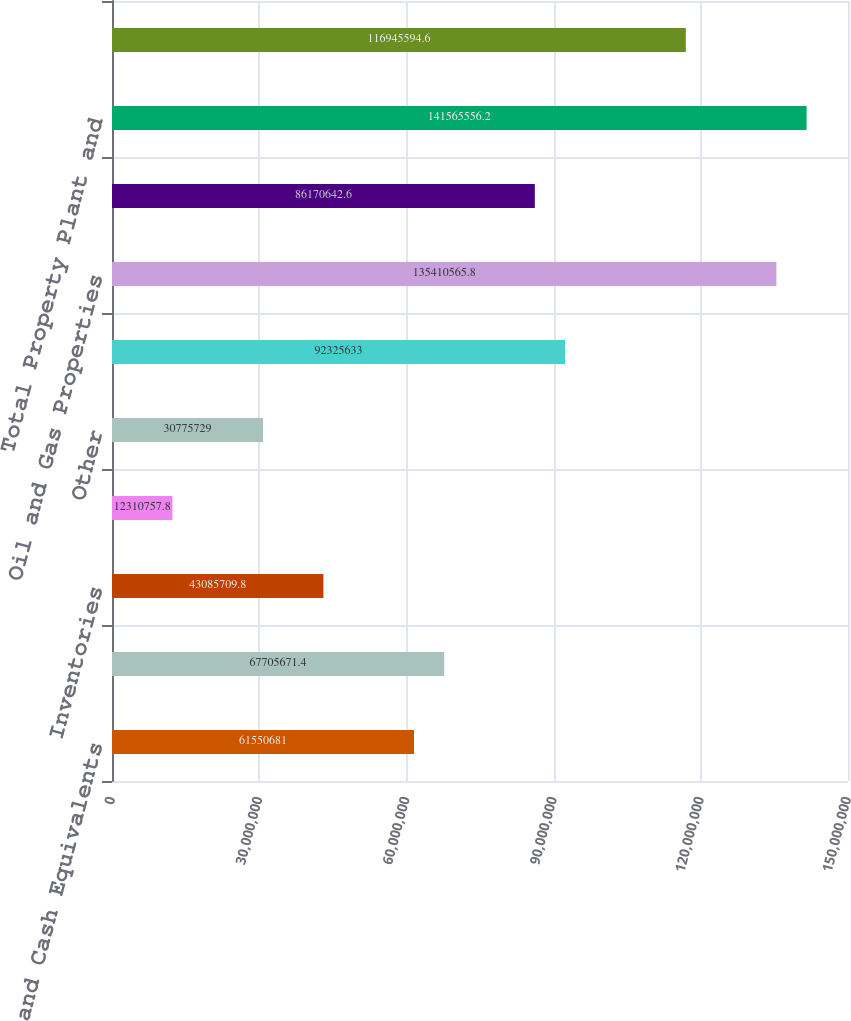Convert chart to OTSL. <chart><loc_0><loc_0><loc_500><loc_500><bar_chart><fcel>Cash and Cash Equivalents<fcel>Accounts Receivable Net<fcel>Inventories<fcel>Assets from Price Risk<fcel>Other<fcel>Property Plant and Equipment<fcel>Oil and Gas Properties<fcel>Other Property Plant and<fcel>Total Property Plant and<fcel>Less Accumulated Depreciation<nl><fcel>6.15507e+07<fcel>6.77057e+07<fcel>4.30857e+07<fcel>1.23108e+07<fcel>3.07757e+07<fcel>9.23256e+07<fcel>1.35411e+08<fcel>8.61706e+07<fcel>1.41566e+08<fcel>1.16946e+08<nl></chart> 